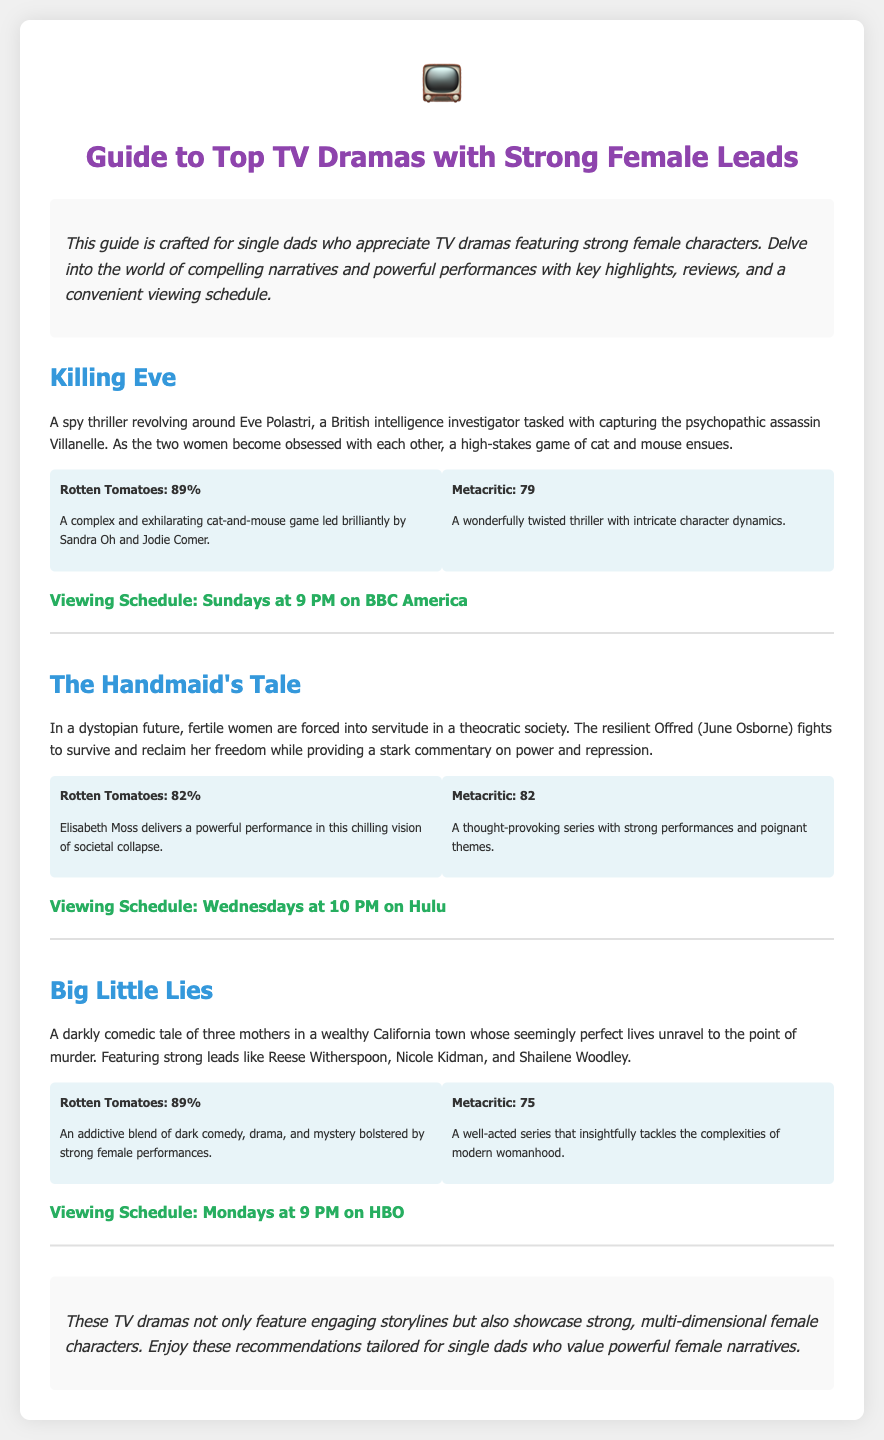What is the title of the guide? The title of the guide is explicitly stated in the document's heading.
Answer: Guide to Top TV Dramas with Strong Female Leads What show features a character named Eve Polastri? Eve Polastri is the protagonist in the show "Killing Eve," described in the synopsis.
Answer: Killing Eve What is the viewing schedule for The Handmaid's Tale? The viewing schedule is found in the section dedicated to The Handmaid's Tale.
Answer: Wednesdays at 10 PM on Hulu What is the Rotten Tomatoes rating for Big Little Lies? The document provides specific ratings for each show, including Big Little Lies.
Answer: 89% Which actress plays a significant role in The Handmaid's Tale? The document mentions the lead actress in The Handmaid's Tale, giving insight into the show's strong female character.
Answer: Elisabeth Moss What type of document is this? The structure and content described indicate the specific type of document it is.
Answer: Diploma How many shows are listed in the guide? The guide contains a specific number of shows detailed within it.
Answer: Three What common theme is highlighted among the shows? The document emphasizes a common quality of the shows presented in the guide.
Answer: Strong female characters 